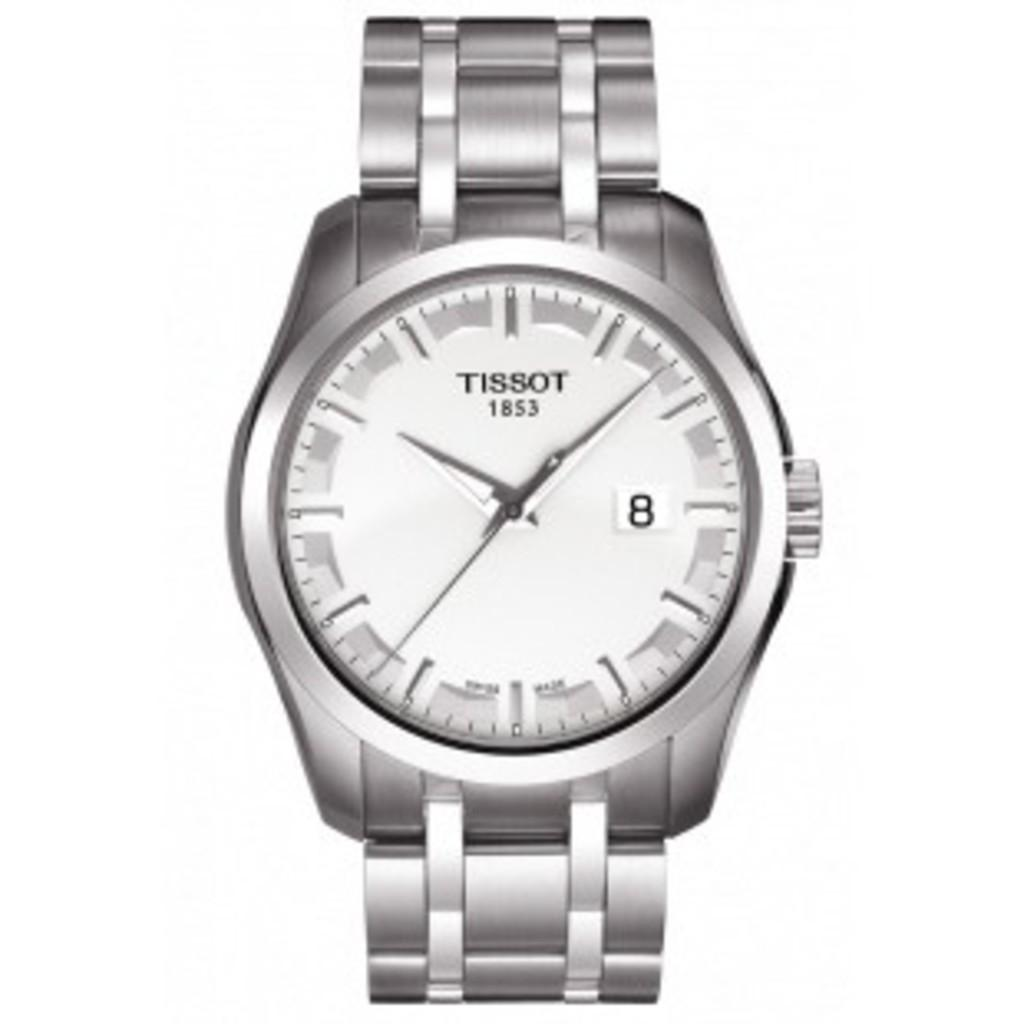<image>
Summarize the visual content of the image. A silver watch that says Tissot 1853 at the top of the watch face. 